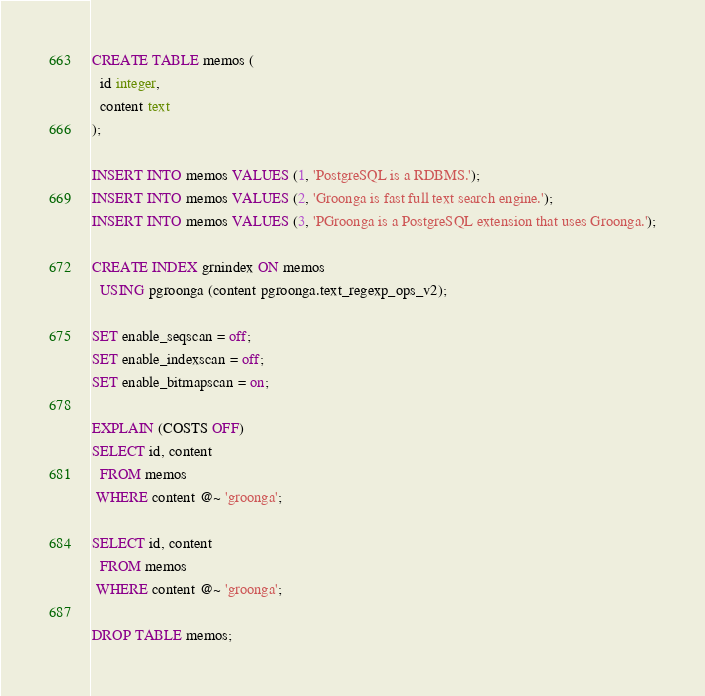Convert code to text. <code><loc_0><loc_0><loc_500><loc_500><_SQL_>CREATE TABLE memos (
  id integer,
  content text
);

INSERT INTO memos VALUES (1, 'PostgreSQL is a RDBMS.');
INSERT INTO memos VALUES (2, 'Groonga is fast full text search engine.');
INSERT INTO memos VALUES (3, 'PGroonga is a PostgreSQL extension that uses Groonga.');

CREATE INDEX grnindex ON memos
  USING pgroonga (content pgroonga.text_regexp_ops_v2);

SET enable_seqscan = off;
SET enable_indexscan = off;
SET enable_bitmapscan = on;

EXPLAIN (COSTS OFF)
SELECT id, content
  FROM memos
 WHERE content @~ 'groonga';

SELECT id, content
  FROM memos
 WHERE content @~ 'groonga';

DROP TABLE memos;
</code> 